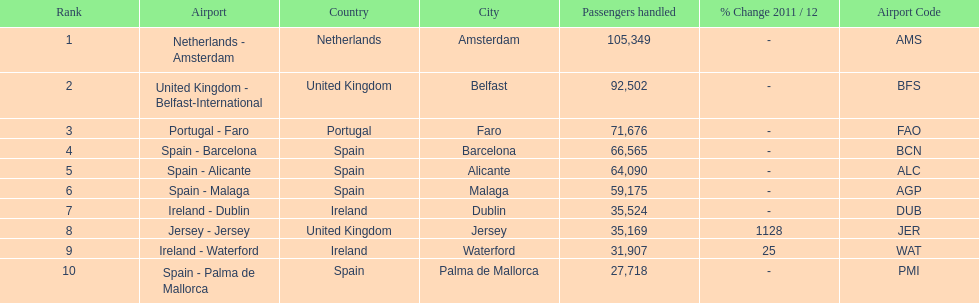Which airport has the least amount of passengers going through london southend airport? Spain - Palma de Mallorca. 